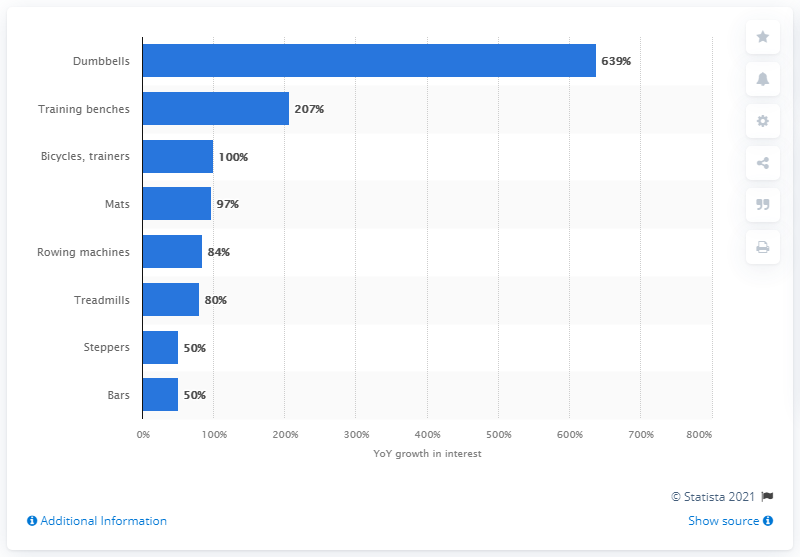Indicate a few pertinent items in this graphic. The equipment that received the most attention was dumbbells. 